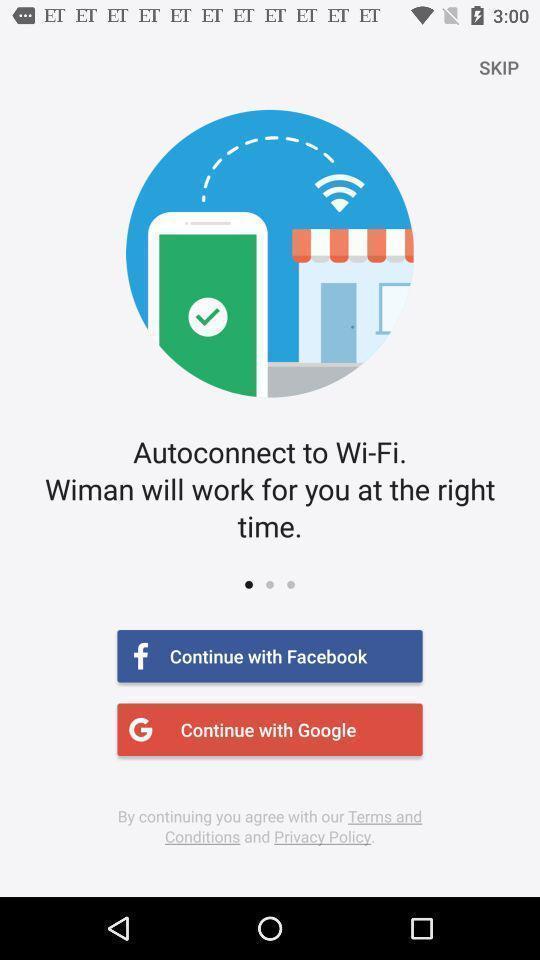Explain the elements present in this screenshot. Welcome page for a wireless internet service app. 